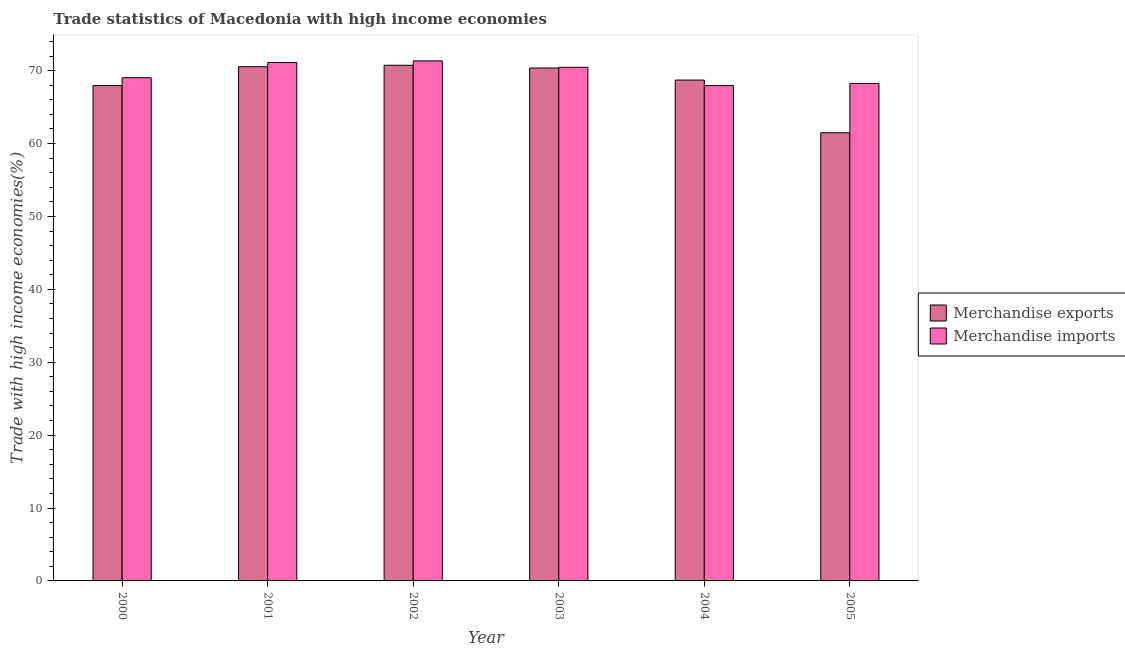How many different coloured bars are there?
Your response must be concise. 2. How many groups of bars are there?
Make the answer very short. 6. How many bars are there on the 1st tick from the left?
Ensure brevity in your answer.  2. How many bars are there on the 3rd tick from the right?
Keep it short and to the point. 2. In how many cases, is the number of bars for a given year not equal to the number of legend labels?
Give a very brief answer. 0. What is the merchandise exports in 2003?
Give a very brief answer. 70.36. Across all years, what is the maximum merchandise exports?
Give a very brief answer. 70.74. Across all years, what is the minimum merchandise exports?
Offer a very short reply. 61.48. In which year was the merchandise exports maximum?
Give a very brief answer. 2002. In which year was the merchandise exports minimum?
Offer a terse response. 2005. What is the total merchandise exports in the graph?
Make the answer very short. 409.78. What is the difference between the merchandise imports in 2000 and that in 2001?
Provide a short and direct response. -2.08. What is the difference between the merchandise imports in 2000 and the merchandise exports in 2001?
Ensure brevity in your answer.  -2.08. What is the average merchandise imports per year?
Make the answer very short. 69.69. In the year 2002, what is the difference between the merchandise imports and merchandise exports?
Keep it short and to the point. 0. In how many years, is the merchandise exports greater than 48 %?
Provide a short and direct response. 6. What is the ratio of the merchandise exports in 2004 to that in 2005?
Provide a succinct answer. 1.12. What is the difference between the highest and the second highest merchandise imports?
Offer a very short reply. 0.23. What is the difference between the highest and the lowest merchandise exports?
Your answer should be compact. 9.26. Is the sum of the merchandise imports in 2000 and 2005 greater than the maximum merchandise exports across all years?
Keep it short and to the point. Yes. What does the 2nd bar from the right in 2005 represents?
Your answer should be very brief. Merchandise exports. Are the values on the major ticks of Y-axis written in scientific E-notation?
Give a very brief answer. No. Where does the legend appear in the graph?
Ensure brevity in your answer.  Center right. How are the legend labels stacked?
Keep it short and to the point. Vertical. What is the title of the graph?
Your answer should be compact. Trade statistics of Macedonia with high income economies. What is the label or title of the X-axis?
Your answer should be very brief. Year. What is the label or title of the Y-axis?
Provide a succinct answer. Trade with high income economies(%). What is the Trade with high income economies(%) in Merchandise exports in 2000?
Make the answer very short. 67.95. What is the Trade with high income economies(%) in Merchandise imports in 2000?
Offer a terse response. 69.03. What is the Trade with high income economies(%) in Merchandise exports in 2001?
Your response must be concise. 70.54. What is the Trade with high income economies(%) of Merchandise imports in 2001?
Give a very brief answer. 71.11. What is the Trade with high income economies(%) in Merchandise exports in 2002?
Give a very brief answer. 70.74. What is the Trade with high income economies(%) in Merchandise imports in 2002?
Provide a short and direct response. 71.34. What is the Trade with high income economies(%) in Merchandise exports in 2003?
Your response must be concise. 70.36. What is the Trade with high income economies(%) in Merchandise imports in 2003?
Give a very brief answer. 70.46. What is the Trade with high income economies(%) of Merchandise exports in 2004?
Your response must be concise. 68.71. What is the Trade with high income economies(%) of Merchandise imports in 2004?
Your answer should be compact. 67.96. What is the Trade with high income economies(%) of Merchandise exports in 2005?
Your answer should be compact. 61.48. What is the Trade with high income economies(%) of Merchandise imports in 2005?
Your answer should be compact. 68.25. Across all years, what is the maximum Trade with high income economies(%) in Merchandise exports?
Ensure brevity in your answer.  70.74. Across all years, what is the maximum Trade with high income economies(%) in Merchandise imports?
Make the answer very short. 71.34. Across all years, what is the minimum Trade with high income economies(%) in Merchandise exports?
Offer a terse response. 61.48. Across all years, what is the minimum Trade with high income economies(%) in Merchandise imports?
Your response must be concise. 67.96. What is the total Trade with high income economies(%) in Merchandise exports in the graph?
Give a very brief answer. 409.78. What is the total Trade with high income economies(%) in Merchandise imports in the graph?
Your response must be concise. 418.14. What is the difference between the Trade with high income economies(%) of Merchandise exports in 2000 and that in 2001?
Offer a terse response. -2.59. What is the difference between the Trade with high income economies(%) in Merchandise imports in 2000 and that in 2001?
Offer a terse response. -2.08. What is the difference between the Trade with high income economies(%) of Merchandise exports in 2000 and that in 2002?
Offer a very short reply. -2.78. What is the difference between the Trade with high income economies(%) of Merchandise imports in 2000 and that in 2002?
Your response must be concise. -2.31. What is the difference between the Trade with high income economies(%) of Merchandise exports in 2000 and that in 2003?
Provide a short and direct response. -2.41. What is the difference between the Trade with high income economies(%) of Merchandise imports in 2000 and that in 2003?
Provide a succinct answer. -1.43. What is the difference between the Trade with high income economies(%) in Merchandise exports in 2000 and that in 2004?
Make the answer very short. -0.75. What is the difference between the Trade with high income economies(%) of Merchandise imports in 2000 and that in 2004?
Provide a succinct answer. 1.07. What is the difference between the Trade with high income economies(%) in Merchandise exports in 2000 and that in 2005?
Ensure brevity in your answer.  6.48. What is the difference between the Trade with high income economies(%) of Merchandise imports in 2000 and that in 2005?
Ensure brevity in your answer.  0.78. What is the difference between the Trade with high income economies(%) of Merchandise exports in 2001 and that in 2002?
Your answer should be compact. -0.2. What is the difference between the Trade with high income economies(%) of Merchandise imports in 2001 and that in 2002?
Make the answer very short. -0.23. What is the difference between the Trade with high income economies(%) in Merchandise exports in 2001 and that in 2003?
Give a very brief answer. 0.18. What is the difference between the Trade with high income economies(%) in Merchandise imports in 2001 and that in 2003?
Your answer should be very brief. 0.65. What is the difference between the Trade with high income economies(%) of Merchandise exports in 2001 and that in 2004?
Ensure brevity in your answer.  1.84. What is the difference between the Trade with high income economies(%) of Merchandise imports in 2001 and that in 2004?
Your response must be concise. 3.16. What is the difference between the Trade with high income economies(%) in Merchandise exports in 2001 and that in 2005?
Offer a terse response. 9.06. What is the difference between the Trade with high income economies(%) in Merchandise imports in 2001 and that in 2005?
Give a very brief answer. 2.87. What is the difference between the Trade with high income economies(%) of Merchandise exports in 2002 and that in 2003?
Give a very brief answer. 0.38. What is the difference between the Trade with high income economies(%) in Merchandise imports in 2002 and that in 2003?
Provide a short and direct response. 0.88. What is the difference between the Trade with high income economies(%) in Merchandise exports in 2002 and that in 2004?
Provide a succinct answer. 2.03. What is the difference between the Trade with high income economies(%) of Merchandise imports in 2002 and that in 2004?
Provide a succinct answer. 3.38. What is the difference between the Trade with high income economies(%) in Merchandise exports in 2002 and that in 2005?
Your response must be concise. 9.26. What is the difference between the Trade with high income economies(%) of Merchandise imports in 2002 and that in 2005?
Provide a short and direct response. 3.09. What is the difference between the Trade with high income economies(%) of Merchandise exports in 2003 and that in 2004?
Offer a very short reply. 1.66. What is the difference between the Trade with high income economies(%) of Merchandise imports in 2003 and that in 2004?
Make the answer very short. 2.51. What is the difference between the Trade with high income economies(%) in Merchandise exports in 2003 and that in 2005?
Provide a short and direct response. 8.88. What is the difference between the Trade with high income economies(%) in Merchandise imports in 2003 and that in 2005?
Offer a terse response. 2.21. What is the difference between the Trade with high income economies(%) of Merchandise exports in 2004 and that in 2005?
Your response must be concise. 7.23. What is the difference between the Trade with high income economies(%) in Merchandise imports in 2004 and that in 2005?
Offer a terse response. -0.29. What is the difference between the Trade with high income economies(%) in Merchandise exports in 2000 and the Trade with high income economies(%) in Merchandise imports in 2001?
Offer a terse response. -3.16. What is the difference between the Trade with high income economies(%) of Merchandise exports in 2000 and the Trade with high income economies(%) of Merchandise imports in 2002?
Your response must be concise. -3.38. What is the difference between the Trade with high income economies(%) of Merchandise exports in 2000 and the Trade with high income economies(%) of Merchandise imports in 2003?
Offer a very short reply. -2.51. What is the difference between the Trade with high income economies(%) in Merchandise exports in 2000 and the Trade with high income economies(%) in Merchandise imports in 2004?
Your answer should be compact. -0. What is the difference between the Trade with high income economies(%) of Merchandise exports in 2000 and the Trade with high income economies(%) of Merchandise imports in 2005?
Offer a terse response. -0.29. What is the difference between the Trade with high income economies(%) in Merchandise exports in 2001 and the Trade with high income economies(%) in Merchandise imports in 2002?
Your answer should be compact. -0.8. What is the difference between the Trade with high income economies(%) in Merchandise exports in 2001 and the Trade with high income economies(%) in Merchandise imports in 2003?
Offer a terse response. 0.08. What is the difference between the Trade with high income economies(%) in Merchandise exports in 2001 and the Trade with high income economies(%) in Merchandise imports in 2004?
Offer a terse response. 2.59. What is the difference between the Trade with high income economies(%) of Merchandise exports in 2001 and the Trade with high income economies(%) of Merchandise imports in 2005?
Provide a succinct answer. 2.3. What is the difference between the Trade with high income economies(%) of Merchandise exports in 2002 and the Trade with high income economies(%) of Merchandise imports in 2003?
Your answer should be compact. 0.28. What is the difference between the Trade with high income economies(%) of Merchandise exports in 2002 and the Trade with high income economies(%) of Merchandise imports in 2004?
Your answer should be compact. 2.78. What is the difference between the Trade with high income economies(%) in Merchandise exports in 2002 and the Trade with high income economies(%) in Merchandise imports in 2005?
Provide a short and direct response. 2.49. What is the difference between the Trade with high income economies(%) in Merchandise exports in 2003 and the Trade with high income economies(%) in Merchandise imports in 2004?
Provide a succinct answer. 2.41. What is the difference between the Trade with high income economies(%) of Merchandise exports in 2003 and the Trade with high income economies(%) of Merchandise imports in 2005?
Provide a succinct answer. 2.12. What is the difference between the Trade with high income economies(%) of Merchandise exports in 2004 and the Trade with high income economies(%) of Merchandise imports in 2005?
Your answer should be compact. 0.46. What is the average Trade with high income economies(%) of Merchandise exports per year?
Provide a succinct answer. 68.3. What is the average Trade with high income economies(%) of Merchandise imports per year?
Your answer should be very brief. 69.69. In the year 2000, what is the difference between the Trade with high income economies(%) of Merchandise exports and Trade with high income economies(%) of Merchandise imports?
Ensure brevity in your answer.  -1.07. In the year 2001, what is the difference between the Trade with high income economies(%) in Merchandise exports and Trade with high income economies(%) in Merchandise imports?
Ensure brevity in your answer.  -0.57. In the year 2002, what is the difference between the Trade with high income economies(%) in Merchandise exports and Trade with high income economies(%) in Merchandise imports?
Keep it short and to the point. -0.6. In the year 2003, what is the difference between the Trade with high income economies(%) in Merchandise exports and Trade with high income economies(%) in Merchandise imports?
Make the answer very short. -0.1. In the year 2004, what is the difference between the Trade with high income economies(%) in Merchandise exports and Trade with high income economies(%) in Merchandise imports?
Make the answer very short. 0.75. In the year 2005, what is the difference between the Trade with high income economies(%) in Merchandise exports and Trade with high income economies(%) in Merchandise imports?
Your answer should be very brief. -6.77. What is the ratio of the Trade with high income economies(%) in Merchandise exports in 2000 to that in 2001?
Offer a terse response. 0.96. What is the ratio of the Trade with high income economies(%) in Merchandise imports in 2000 to that in 2001?
Ensure brevity in your answer.  0.97. What is the ratio of the Trade with high income economies(%) of Merchandise exports in 2000 to that in 2002?
Your response must be concise. 0.96. What is the ratio of the Trade with high income economies(%) of Merchandise imports in 2000 to that in 2002?
Offer a very short reply. 0.97. What is the ratio of the Trade with high income economies(%) of Merchandise exports in 2000 to that in 2003?
Offer a very short reply. 0.97. What is the ratio of the Trade with high income economies(%) of Merchandise imports in 2000 to that in 2003?
Give a very brief answer. 0.98. What is the ratio of the Trade with high income economies(%) in Merchandise imports in 2000 to that in 2004?
Provide a succinct answer. 1.02. What is the ratio of the Trade with high income economies(%) in Merchandise exports in 2000 to that in 2005?
Your answer should be very brief. 1.11. What is the ratio of the Trade with high income economies(%) in Merchandise imports in 2000 to that in 2005?
Keep it short and to the point. 1.01. What is the ratio of the Trade with high income economies(%) of Merchandise exports in 2001 to that in 2002?
Provide a succinct answer. 1. What is the ratio of the Trade with high income economies(%) in Merchandise imports in 2001 to that in 2002?
Keep it short and to the point. 1. What is the ratio of the Trade with high income economies(%) in Merchandise exports in 2001 to that in 2003?
Give a very brief answer. 1. What is the ratio of the Trade with high income economies(%) in Merchandise imports in 2001 to that in 2003?
Provide a short and direct response. 1.01. What is the ratio of the Trade with high income economies(%) of Merchandise exports in 2001 to that in 2004?
Give a very brief answer. 1.03. What is the ratio of the Trade with high income economies(%) in Merchandise imports in 2001 to that in 2004?
Provide a succinct answer. 1.05. What is the ratio of the Trade with high income economies(%) in Merchandise exports in 2001 to that in 2005?
Provide a short and direct response. 1.15. What is the ratio of the Trade with high income economies(%) in Merchandise imports in 2001 to that in 2005?
Provide a succinct answer. 1.04. What is the ratio of the Trade with high income economies(%) in Merchandise exports in 2002 to that in 2003?
Keep it short and to the point. 1.01. What is the ratio of the Trade with high income economies(%) in Merchandise imports in 2002 to that in 2003?
Make the answer very short. 1.01. What is the ratio of the Trade with high income economies(%) in Merchandise exports in 2002 to that in 2004?
Offer a very short reply. 1.03. What is the ratio of the Trade with high income economies(%) in Merchandise imports in 2002 to that in 2004?
Provide a succinct answer. 1.05. What is the ratio of the Trade with high income economies(%) of Merchandise exports in 2002 to that in 2005?
Your answer should be compact. 1.15. What is the ratio of the Trade with high income economies(%) in Merchandise imports in 2002 to that in 2005?
Provide a short and direct response. 1.05. What is the ratio of the Trade with high income economies(%) in Merchandise exports in 2003 to that in 2004?
Offer a very short reply. 1.02. What is the ratio of the Trade with high income economies(%) in Merchandise imports in 2003 to that in 2004?
Keep it short and to the point. 1.04. What is the ratio of the Trade with high income economies(%) in Merchandise exports in 2003 to that in 2005?
Your response must be concise. 1.14. What is the ratio of the Trade with high income economies(%) of Merchandise imports in 2003 to that in 2005?
Your answer should be compact. 1.03. What is the ratio of the Trade with high income economies(%) in Merchandise exports in 2004 to that in 2005?
Give a very brief answer. 1.12. What is the ratio of the Trade with high income economies(%) in Merchandise imports in 2004 to that in 2005?
Make the answer very short. 1. What is the difference between the highest and the second highest Trade with high income economies(%) of Merchandise exports?
Make the answer very short. 0.2. What is the difference between the highest and the second highest Trade with high income economies(%) of Merchandise imports?
Your answer should be compact. 0.23. What is the difference between the highest and the lowest Trade with high income economies(%) in Merchandise exports?
Your answer should be compact. 9.26. What is the difference between the highest and the lowest Trade with high income economies(%) of Merchandise imports?
Provide a succinct answer. 3.38. 